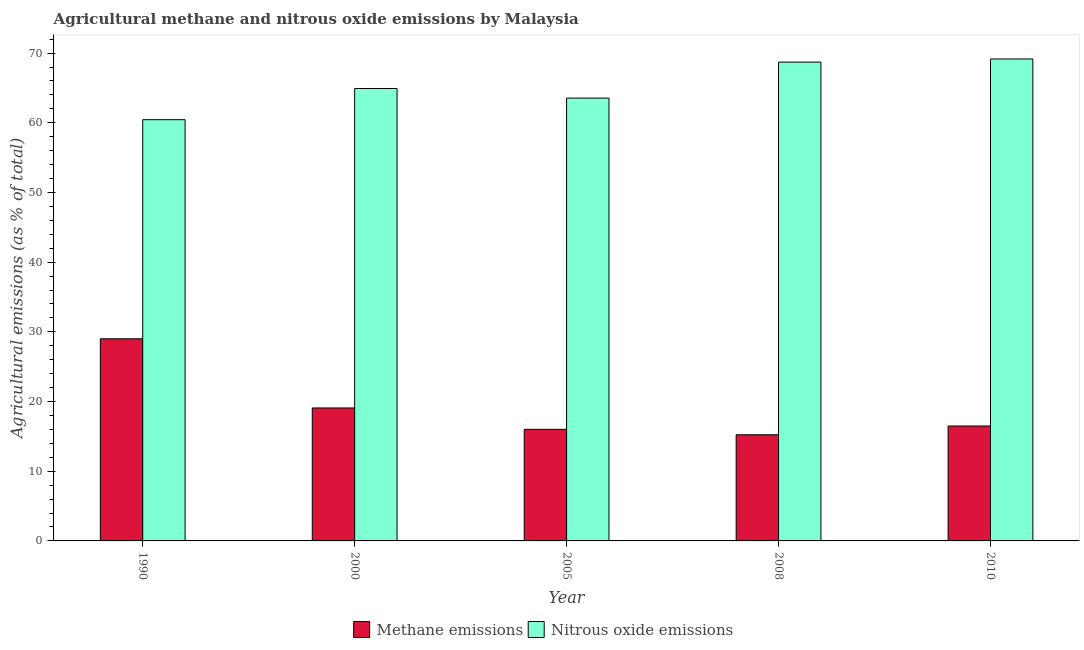How many different coloured bars are there?
Your response must be concise. 2. Are the number of bars per tick equal to the number of legend labels?
Your response must be concise. Yes. Are the number of bars on each tick of the X-axis equal?
Give a very brief answer. Yes. How many bars are there on the 2nd tick from the left?
Offer a terse response. 2. What is the label of the 3rd group of bars from the left?
Your answer should be very brief. 2005. What is the amount of methane emissions in 2008?
Your answer should be very brief. 15.23. Across all years, what is the maximum amount of nitrous oxide emissions?
Provide a short and direct response. 69.16. Across all years, what is the minimum amount of nitrous oxide emissions?
Give a very brief answer. 60.44. What is the total amount of nitrous oxide emissions in the graph?
Keep it short and to the point. 326.76. What is the difference between the amount of nitrous oxide emissions in 1990 and that in 2010?
Keep it short and to the point. -8.71. What is the difference between the amount of methane emissions in 1990 and the amount of nitrous oxide emissions in 2010?
Provide a succinct answer. 12.51. What is the average amount of nitrous oxide emissions per year?
Make the answer very short. 65.35. In the year 2000, what is the difference between the amount of methane emissions and amount of nitrous oxide emissions?
Keep it short and to the point. 0. What is the ratio of the amount of methane emissions in 2005 to that in 2008?
Make the answer very short. 1.05. What is the difference between the highest and the second highest amount of methane emissions?
Provide a short and direct response. 9.92. What is the difference between the highest and the lowest amount of methane emissions?
Give a very brief answer. 13.77. In how many years, is the amount of nitrous oxide emissions greater than the average amount of nitrous oxide emissions taken over all years?
Your response must be concise. 2. What does the 1st bar from the left in 1990 represents?
Ensure brevity in your answer.  Methane emissions. What does the 2nd bar from the right in 2000 represents?
Offer a terse response. Methane emissions. How many bars are there?
Your response must be concise. 10. How many years are there in the graph?
Offer a terse response. 5. Does the graph contain any zero values?
Provide a succinct answer. No. Where does the legend appear in the graph?
Provide a succinct answer. Bottom center. How are the legend labels stacked?
Offer a very short reply. Horizontal. What is the title of the graph?
Your response must be concise. Agricultural methane and nitrous oxide emissions by Malaysia. What is the label or title of the X-axis?
Your response must be concise. Year. What is the label or title of the Y-axis?
Offer a very short reply. Agricultural emissions (as % of total). What is the Agricultural emissions (as % of total) in Methane emissions in 1990?
Offer a very short reply. 29. What is the Agricultural emissions (as % of total) of Nitrous oxide emissions in 1990?
Keep it short and to the point. 60.44. What is the Agricultural emissions (as % of total) of Methane emissions in 2000?
Make the answer very short. 19.08. What is the Agricultural emissions (as % of total) in Nitrous oxide emissions in 2000?
Provide a succinct answer. 64.92. What is the Agricultural emissions (as % of total) in Methane emissions in 2005?
Your answer should be compact. 16.01. What is the Agricultural emissions (as % of total) in Nitrous oxide emissions in 2005?
Provide a short and direct response. 63.54. What is the Agricultural emissions (as % of total) in Methane emissions in 2008?
Offer a terse response. 15.23. What is the Agricultural emissions (as % of total) in Nitrous oxide emissions in 2008?
Your answer should be compact. 68.7. What is the Agricultural emissions (as % of total) in Methane emissions in 2010?
Provide a succinct answer. 16.49. What is the Agricultural emissions (as % of total) in Nitrous oxide emissions in 2010?
Offer a terse response. 69.16. Across all years, what is the maximum Agricultural emissions (as % of total) in Methane emissions?
Offer a very short reply. 29. Across all years, what is the maximum Agricultural emissions (as % of total) in Nitrous oxide emissions?
Your answer should be compact. 69.16. Across all years, what is the minimum Agricultural emissions (as % of total) of Methane emissions?
Offer a terse response. 15.23. Across all years, what is the minimum Agricultural emissions (as % of total) of Nitrous oxide emissions?
Offer a very short reply. 60.44. What is the total Agricultural emissions (as % of total) of Methane emissions in the graph?
Provide a succinct answer. 95.81. What is the total Agricultural emissions (as % of total) in Nitrous oxide emissions in the graph?
Your answer should be very brief. 326.76. What is the difference between the Agricultural emissions (as % of total) of Methane emissions in 1990 and that in 2000?
Offer a terse response. 9.92. What is the difference between the Agricultural emissions (as % of total) in Nitrous oxide emissions in 1990 and that in 2000?
Offer a terse response. -4.47. What is the difference between the Agricultural emissions (as % of total) of Methane emissions in 1990 and that in 2005?
Your answer should be very brief. 12.99. What is the difference between the Agricultural emissions (as % of total) of Nitrous oxide emissions in 1990 and that in 2005?
Your answer should be compact. -3.1. What is the difference between the Agricultural emissions (as % of total) in Methane emissions in 1990 and that in 2008?
Provide a short and direct response. 13.77. What is the difference between the Agricultural emissions (as % of total) of Nitrous oxide emissions in 1990 and that in 2008?
Offer a terse response. -8.26. What is the difference between the Agricultural emissions (as % of total) of Methane emissions in 1990 and that in 2010?
Your answer should be compact. 12.51. What is the difference between the Agricultural emissions (as % of total) in Nitrous oxide emissions in 1990 and that in 2010?
Your answer should be compact. -8.71. What is the difference between the Agricultural emissions (as % of total) of Methane emissions in 2000 and that in 2005?
Keep it short and to the point. 3.07. What is the difference between the Agricultural emissions (as % of total) in Nitrous oxide emissions in 2000 and that in 2005?
Your answer should be compact. 1.38. What is the difference between the Agricultural emissions (as % of total) of Methane emissions in 2000 and that in 2008?
Make the answer very short. 3.85. What is the difference between the Agricultural emissions (as % of total) of Nitrous oxide emissions in 2000 and that in 2008?
Provide a short and direct response. -3.79. What is the difference between the Agricultural emissions (as % of total) in Methane emissions in 2000 and that in 2010?
Offer a very short reply. 2.59. What is the difference between the Agricultural emissions (as % of total) in Nitrous oxide emissions in 2000 and that in 2010?
Ensure brevity in your answer.  -4.24. What is the difference between the Agricultural emissions (as % of total) in Methane emissions in 2005 and that in 2008?
Offer a very short reply. 0.78. What is the difference between the Agricultural emissions (as % of total) in Nitrous oxide emissions in 2005 and that in 2008?
Offer a terse response. -5.16. What is the difference between the Agricultural emissions (as % of total) of Methane emissions in 2005 and that in 2010?
Provide a succinct answer. -0.48. What is the difference between the Agricultural emissions (as % of total) in Nitrous oxide emissions in 2005 and that in 2010?
Give a very brief answer. -5.62. What is the difference between the Agricultural emissions (as % of total) of Methane emissions in 2008 and that in 2010?
Your answer should be very brief. -1.26. What is the difference between the Agricultural emissions (as % of total) in Nitrous oxide emissions in 2008 and that in 2010?
Your answer should be very brief. -0.45. What is the difference between the Agricultural emissions (as % of total) in Methane emissions in 1990 and the Agricultural emissions (as % of total) in Nitrous oxide emissions in 2000?
Ensure brevity in your answer.  -35.92. What is the difference between the Agricultural emissions (as % of total) of Methane emissions in 1990 and the Agricultural emissions (as % of total) of Nitrous oxide emissions in 2005?
Your response must be concise. -34.54. What is the difference between the Agricultural emissions (as % of total) of Methane emissions in 1990 and the Agricultural emissions (as % of total) of Nitrous oxide emissions in 2008?
Give a very brief answer. -39.7. What is the difference between the Agricultural emissions (as % of total) of Methane emissions in 1990 and the Agricultural emissions (as % of total) of Nitrous oxide emissions in 2010?
Keep it short and to the point. -40.15. What is the difference between the Agricultural emissions (as % of total) of Methane emissions in 2000 and the Agricultural emissions (as % of total) of Nitrous oxide emissions in 2005?
Give a very brief answer. -44.46. What is the difference between the Agricultural emissions (as % of total) of Methane emissions in 2000 and the Agricultural emissions (as % of total) of Nitrous oxide emissions in 2008?
Provide a short and direct response. -49.62. What is the difference between the Agricultural emissions (as % of total) of Methane emissions in 2000 and the Agricultural emissions (as % of total) of Nitrous oxide emissions in 2010?
Ensure brevity in your answer.  -50.08. What is the difference between the Agricultural emissions (as % of total) in Methane emissions in 2005 and the Agricultural emissions (as % of total) in Nitrous oxide emissions in 2008?
Your response must be concise. -52.69. What is the difference between the Agricultural emissions (as % of total) in Methane emissions in 2005 and the Agricultural emissions (as % of total) in Nitrous oxide emissions in 2010?
Your response must be concise. -53.14. What is the difference between the Agricultural emissions (as % of total) in Methane emissions in 2008 and the Agricultural emissions (as % of total) in Nitrous oxide emissions in 2010?
Offer a terse response. -53.92. What is the average Agricultural emissions (as % of total) in Methane emissions per year?
Provide a short and direct response. 19.16. What is the average Agricultural emissions (as % of total) in Nitrous oxide emissions per year?
Your response must be concise. 65.35. In the year 1990, what is the difference between the Agricultural emissions (as % of total) of Methane emissions and Agricultural emissions (as % of total) of Nitrous oxide emissions?
Offer a terse response. -31.44. In the year 2000, what is the difference between the Agricultural emissions (as % of total) in Methane emissions and Agricultural emissions (as % of total) in Nitrous oxide emissions?
Offer a terse response. -45.84. In the year 2005, what is the difference between the Agricultural emissions (as % of total) of Methane emissions and Agricultural emissions (as % of total) of Nitrous oxide emissions?
Provide a succinct answer. -47.53. In the year 2008, what is the difference between the Agricultural emissions (as % of total) of Methane emissions and Agricultural emissions (as % of total) of Nitrous oxide emissions?
Ensure brevity in your answer.  -53.47. In the year 2010, what is the difference between the Agricultural emissions (as % of total) of Methane emissions and Agricultural emissions (as % of total) of Nitrous oxide emissions?
Provide a short and direct response. -52.67. What is the ratio of the Agricultural emissions (as % of total) of Methane emissions in 1990 to that in 2000?
Offer a terse response. 1.52. What is the ratio of the Agricultural emissions (as % of total) of Nitrous oxide emissions in 1990 to that in 2000?
Keep it short and to the point. 0.93. What is the ratio of the Agricultural emissions (as % of total) of Methane emissions in 1990 to that in 2005?
Offer a terse response. 1.81. What is the ratio of the Agricultural emissions (as % of total) in Nitrous oxide emissions in 1990 to that in 2005?
Make the answer very short. 0.95. What is the ratio of the Agricultural emissions (as % of total) of Methane emissions in 1990 to that in 2008?
Your response must be concise. 1.9. What is the ratio of the Agricultural emissions (as % of total) in Nitrous oxide emissions in 1990 to that in 2008?
Offer a terse response. 0.88. What is the ratio of the Agricultural emissions (as % of total) in Methane emissions in 1990 to that in 2010?
Ensure brevity in your answer.  1.76. What is the ratio of the Agricultural emissions (as % of total) in Nitrous oxide emissions in 1990 to that in 2010?
Make the answer very short. 0.87. What is the ratio of the Agricultural emissions (as % of total) of Methane emissions in 2000 to that in 2005?
Your answer should be compact. 1.19. What is the ratio of the Agricultural emissions (as % of total) in Nitrous oxide emissions in 2000 to that in 2005?
Your answer should be compact. 1.02. What is the ratio of the Agricultural emissions (as % of total) of Methane emissions in 2000 to that in 2008?
Give a very brief answer. 1.25. What is the ratio of the Agricultural emissions (as % of total) in Nitrous oxide emissions in 2000 to that in 2008?
Offer a terse response. 0.94. What is the ratio of the Agricultural emissions (as % of total) in Methane emissions in 2000 to that in 2010?
Offer a very short reply. 1.16. What is the ratio of the Agricultural emissions (as % of total) in Nitrous oxide emissions in 2000 to that in 2010?
Your answer should be compact. 0.94. What is the ratio of the Agricultural emissions (as % of total) in Methane emissions in 2005 to that in 2008?
Provide a succinct answer. 1.05. What is the ratio of the Agricultural emissions (as % of total) in Nitrous oxide emissions in 2005 to that in 2008?
Your answer should be very brief. 0.92. What is the ratio of the Agricultural emissions (as % of total) in Methane emissions in 2005 to that in 2010?
Your answer should be compact. 0.97. What is the ratio of the Agricultural emissions (as % of total) in Nitrous oxide emissions in 2005 to that in 2010?
Give a very brief answer. 0.92. What is the ratio of the Agricultural emissions (as % of total) of Methane emissions in 2008 to that in 2010?
Provide a short and direct response. 0.92. What is the ratio of the Agricultural emissions (as % of total) of Nitrous oxide emissions in 2008 to that in 2010?
Make the answer very short. 0.99. What is the difference between the highest and the second highest Agricultural emissions (as % of total) in Methane emissions?
Give a very brief answer. 9.92. What is the difference between the highest and the second highest Agricultural emissions (as % of total) in Nitrous oxide emissions?
Your answer should be compact. 0.45. What is the difference between the highest and the lowest Agricultural emissions (as % of total) in Methane emissions?
Your answer should be compact. 13.77. What is the difference between the highest and the lowest Agricultural emissions (as % of total) of Nitrous oxide emissions?
Your answer should be compact. 8.71. 